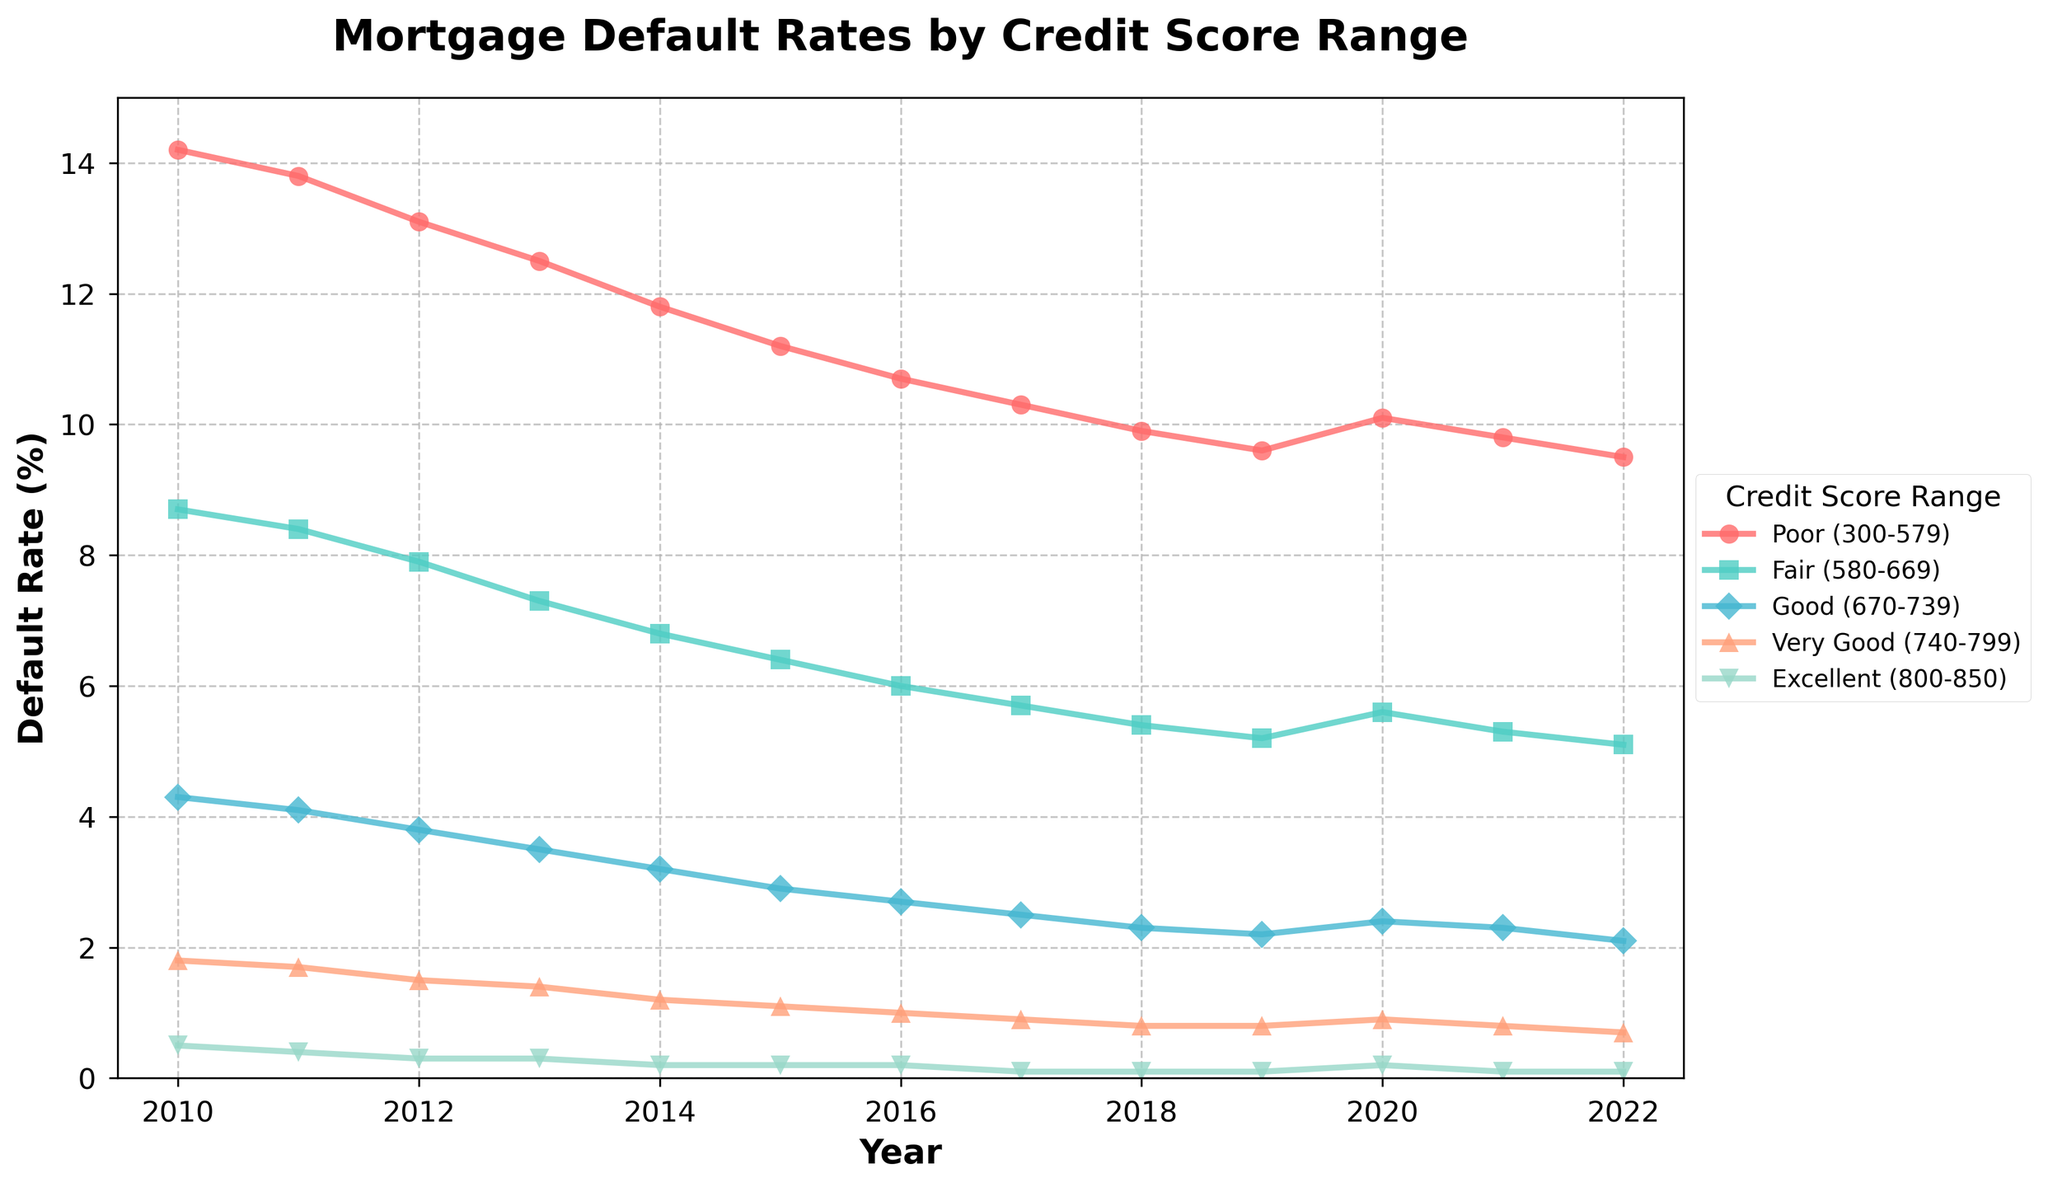What is the default rate for the "Fair" credit score range in 2015? Locate the plot for the "Fair" credit score range, which is represented by a specific color and marker, then find the data point corresponding to the year 2015.
Answer: 6.4 Which credit score range saw the largest decrease in default rates from 2010 to 2022? Calculate the difference in default rates between 2010 and 2022 for each credit score range and identify the one with the largest decrease. For example, "Poor" went from 14.2 to 9.5, giving a decrease of 4.7. Repeat this for all ranges and compare.
Answer: Poor (300-579) In which year did the "Excellent" credit score range experience its highest default rate? Examine the trend line for the "Excellent" credit score range and identify the year with the highest data point.
Answer: 2010 How does the default rate for the "Good" credit score range in 2012 compare to that in 2019? Locate the "Good" credit score range's data points for 2012 and 2019, then compare the two values.
Answer: The default rate in 2019 is lower than in 2012 Which credit score range had the most stable default rate from 2010 to 2022? Review all the trend lines and identify the one that shows the least variation over the years.
Answer: Excellent (800-850) What is the average default rate for the "Very Good" credit score range from 2010 to 2022? Add the default rates for the "Very Good" credit score range from 2010 to 2022 and divide by the number of years. (1.8 + 1.7 + 1.5 + 1.4 + 1.2 + 1.1 + 1.0 + 0.9 + 0.8 + 0.8 + 0.9 + 0.8 + 0.7) / 13 = 1.07
Answer: 1.07 Which year had the largest overall decrease in the default rate for the "Poor" credit score range from the previous year? Calculate the year-over-year difference in default rates for the "Poor" credit score range and find the year with the largest decrease. (e.g., 14.2 - 13.8 = 0.4 for 2010 to 2011, etc.)
Answer: 2013 During which three consecutive years did the "Fair" credit score range experience a consistent decline in default rates? Examine the trend line for the "Fair" credit score range to identify any three consecutive years with a downward slope.
Answer: 2012-2014 Compare the default rate trend for "Poor" and "Excellent" credit score ranges. Which one shows a more noticeable improvement over the years? Analyze the trends for both "Poor" and "Excellent" credit score ranges and determine which one shows a steeper decline in default rates from 2010 to 2022.
Answer: Poor (300-579) In 2020, which credit score range experienced an increase in default rates compared to 2019? Compare the 2019 and 2020 data points for each credit score range and identify the ones where the default rate increased in 2020.
Answer: Poor (300-579), Fair (580-669), and Very Good (740-799) 